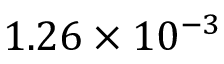<formula> <loc_0><loc_0><loc_500><loc_500>1 . 2 6 \times 1 0 ^ { - 3 }</formula> 